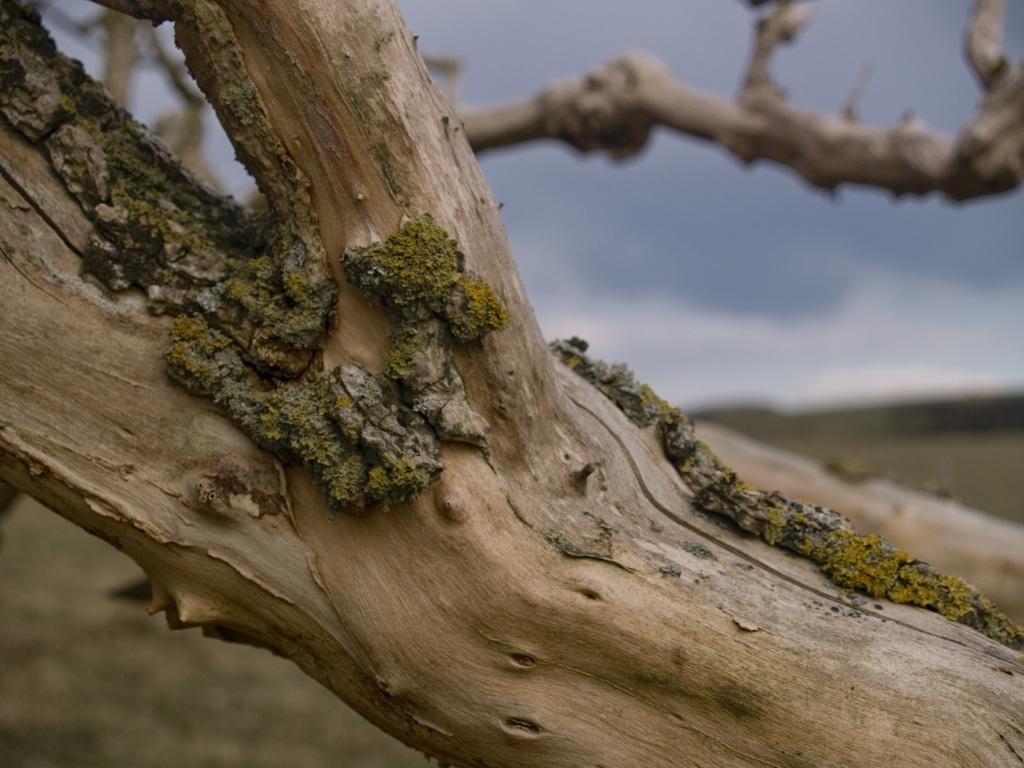Describe this image in one or two sentences. This image consists of a stem which is in the center and the background is blurry. 